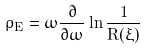Convert formula to latex. <formula><loc_0><loc_0><loc_500><loc_500>\rho _ { E } = \omega \frac { \partial } { \partial \omega } \ln \frac { 1 } { R ( \xi ) }</formula> 